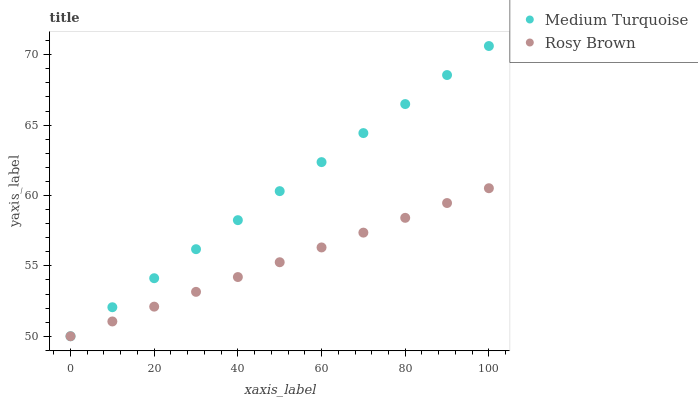Does Rosy Brown have the minimum area under the curve?
Answer yes or no. Yes. Does Medium Turquoise have the maximum area under the curve?
Answer yes or no. Yes. Does Medium Turquoise have the minimum area under the curve?
Answer yes or no. No. Is Rosy Brown the smoothest?
Answer yes or no. Yes. Is Medium Turquoise the roughest?
Answer yes or no. Yes. Is Medium Turquoise the smoothest?
Answer yes or no. No. Does Rosy Brown have the lowest value?
Answer yes or no. Yes. Does Medium Turquoise have the highest value?
Answer yes or no. Yes. Does Rosy Brown intersect Medium Turquoise?
Answer yes or no. Yes. Is Rosy Brown less than Medium Turquoise?
Answer yes or no. No. Is Rosy Brown greater than Medium Turquoise?
Answer yes or no. No. 